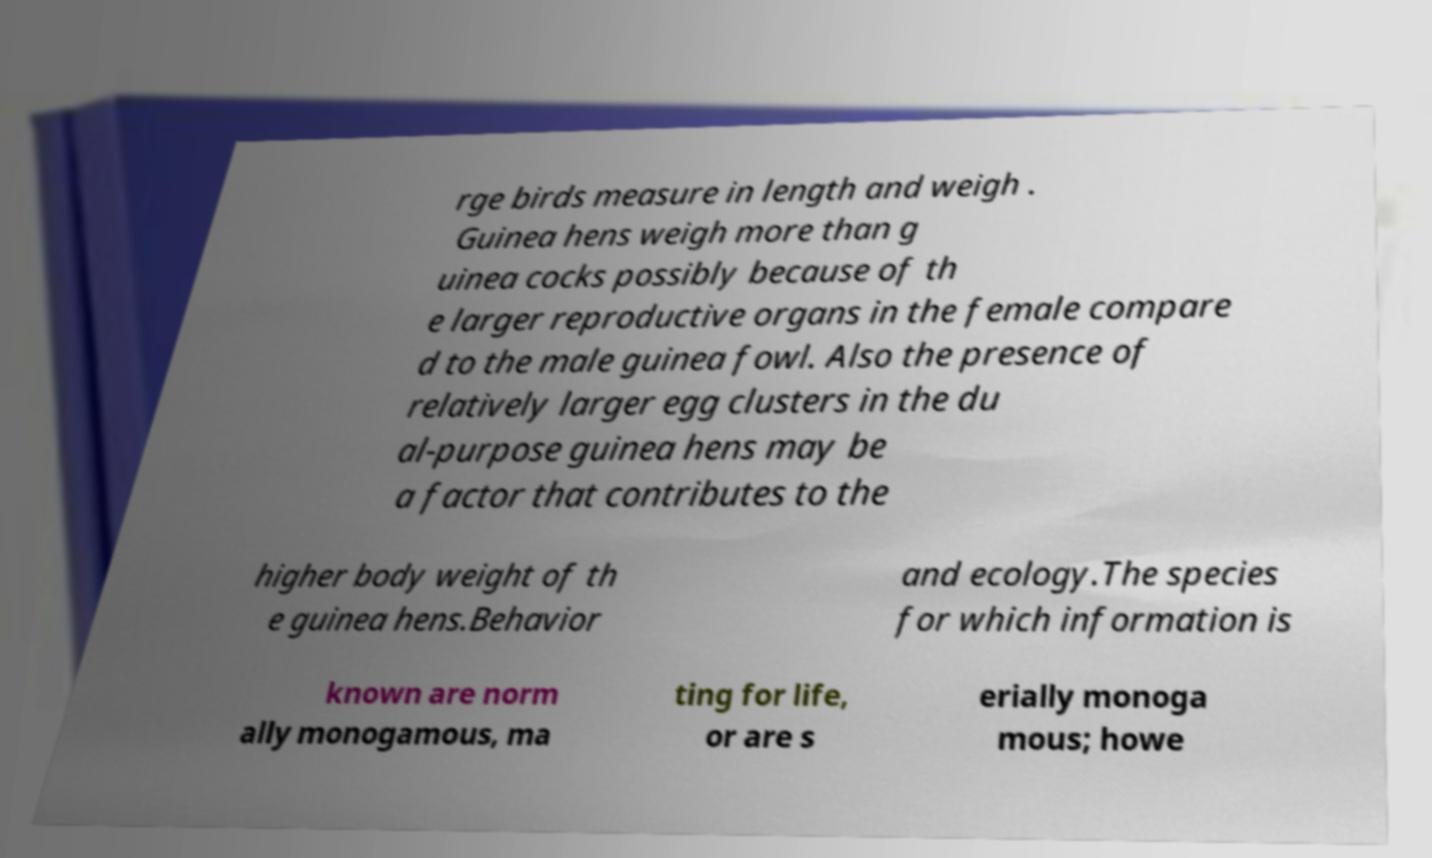Could you assist in decoding the text presented in this image and type it out clearly? rge birds measure in length and weigh . Guinea hens weigh more than g uinea cocks possibly because of th e larger reproductive organs in the female compare d to the male guinea fowl. Also the presence of relatively larger egg clusters in the du al-purpose guinea hens may be a factor that contributes to the higher body weight of th e guinea hens.Behavior and ecology.The species for which information is known are norm ally monogamous, ma ting for life, or are s erially monoga mous; howe 